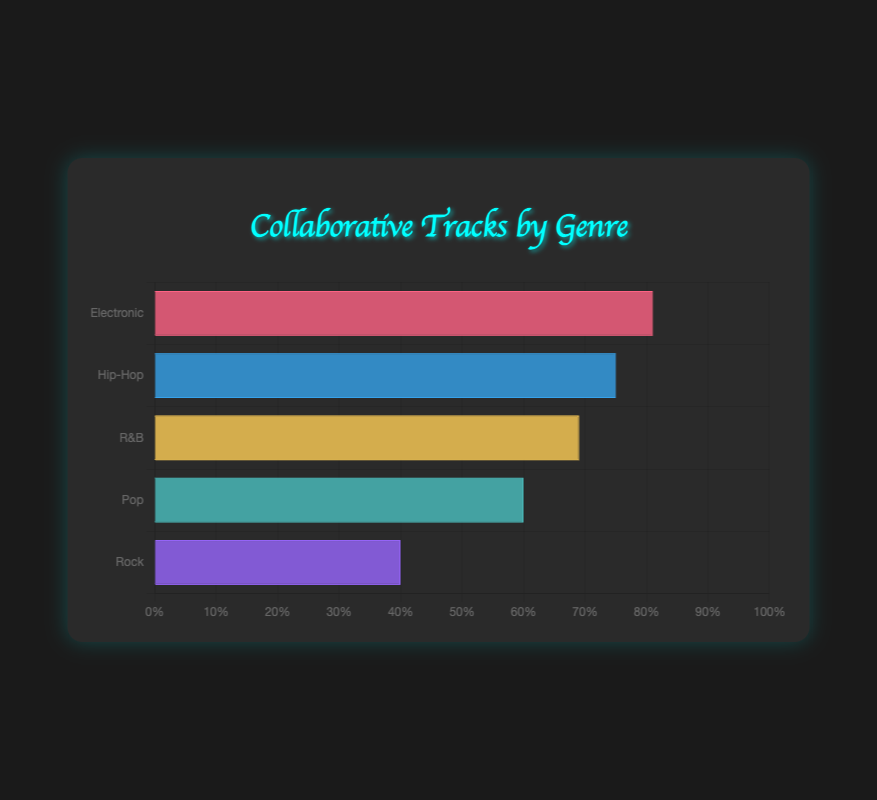Which genre has the highest average proportion of collaborative tracks with vocalists? By looking at the bars in the horizontal bar chart, it's clear that the Electronic genre has the tallest bar, indicating the highest average proportion of collaborative tracks with vocalists.
Answer: Electronic Which genre has the lowest average proportion of collaborative tracks with vocalists? The Rock genre has the shortest bar in the horizontal bar chart, indicating it has the lowest average proportion of collaborative tracks with vocalists.
Answer: Rock How much greater is the average collaborative track percentage in Hip-Hop compared to Rock? The average percentage for Hip-Hop is around 75%, and for Rock, it's around 40%. Subtracting Rock's percentage from Hip-Hop's gives: 75% - 40% = 35%.
Answer: 35% Are there any genres with an average collaborative track percentage less than 50%? By examining the bar heights, only the Rock genre has a bar that is below the 50% mark.
Answer: Yes, Rock What is the average percentage of collaborative tracks for R&B and Pop combined? R&B has an average percentage around 69%, and Pop is around 60%. Adding them gives 69% + 60% = 129%, and averaging them gives 129% / 2 = 64.5%.
Answer: 64.5% Which genre's average percentage of collaborative tracks is closest to 70%? By observing the bar lengths, the Hip-Hop genre has an average percentage closest to 70%.
Answer: Hip-Hop Which genres have an average collaborative track percentage higher than Hip-Hop? By comparing the bar lengths, Electronic is the only genre with a higher average percentage (around 81%) than Hip-Hop (around 75%).
Answer: Electronic How much does the average collaborative track percentage in Electronic exceed the average in Pop? The average percentage for Electronic is around 81%, and for Pop, it's around 60%. Subtracting Pop's percentage from Electronic's gives: 81% - 60% = 21%.
Answer: 21% How does the average collaborative track percentage of R&B compare to that of Hip-Hop? By looking at the bar heights, R&B has a slightly lower average (around 69%) compared to Hip-Hop (around 75%).
Answer: R&B is lower What is the range of average collaborative track percentages across all genres? The highest average is in Electronic (around 81%) and the lowest is in Rock (around 40%). The range is 81% - 40% = 41%.
Answer: 41% 